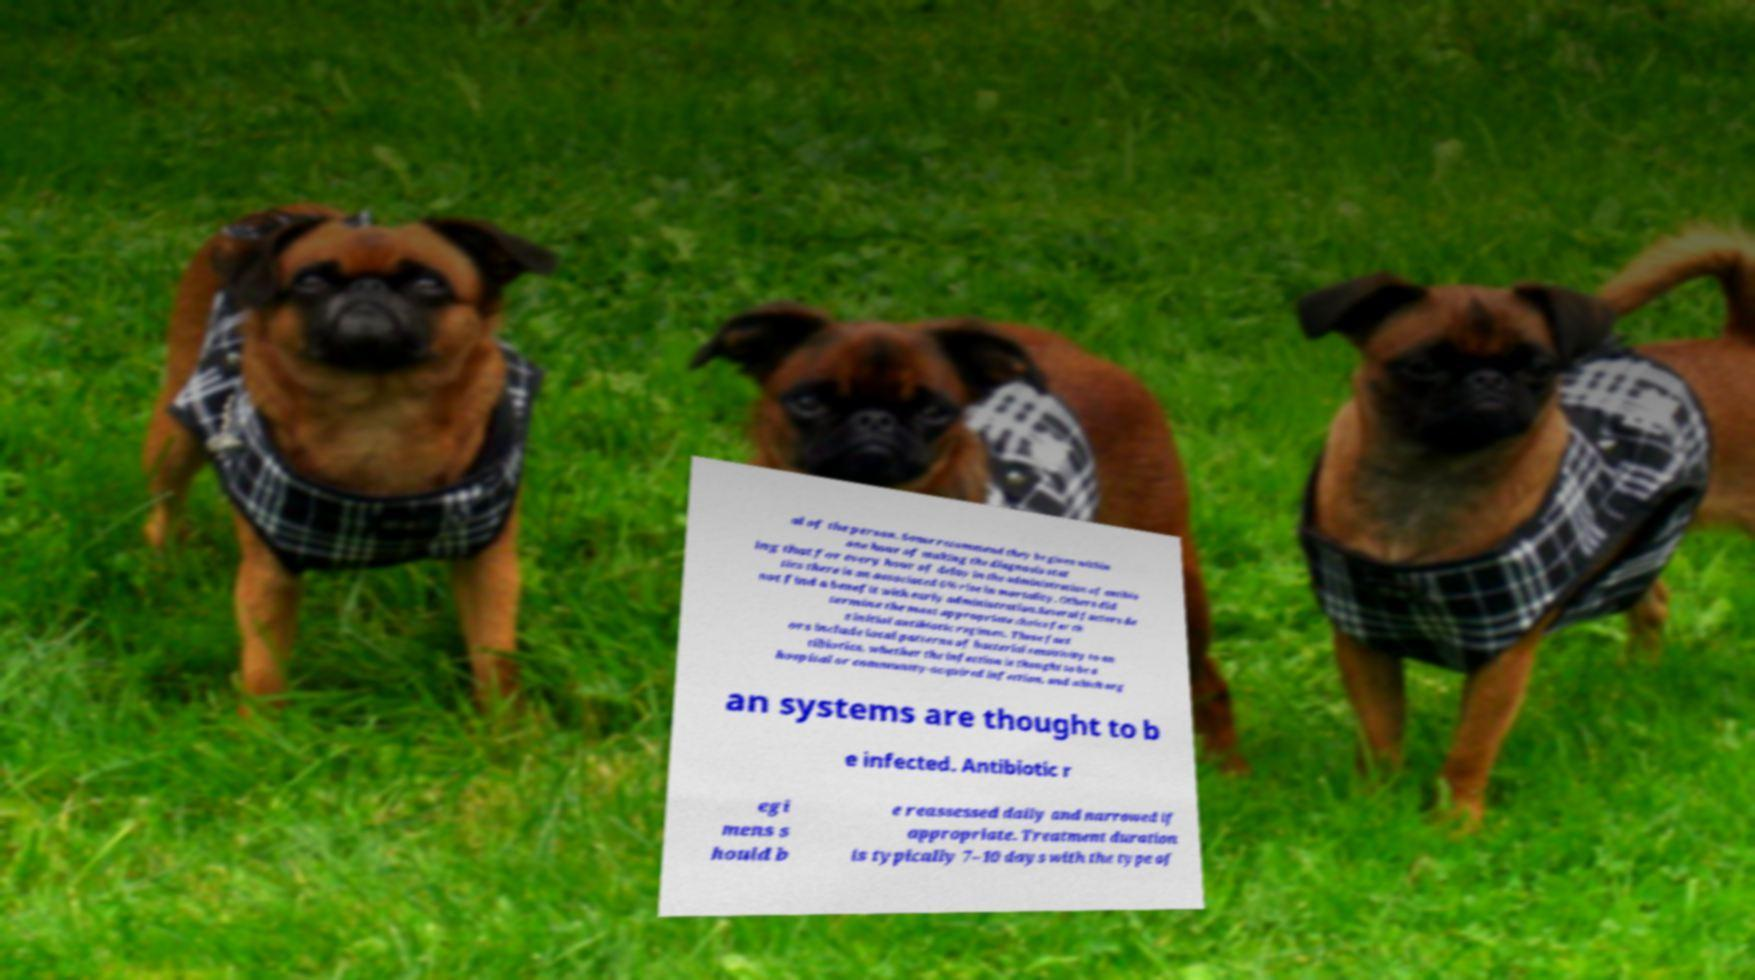Can you accurately transcribe the text from the provided image for me? al of the person. Some recommend they be given within one hour of making the diagnosis stat ing that for every hour of delay in the administration of antibio tics there is an associated 6% rise in mortality. Others did not find a benefit with early administration.Several factors de termine the most appropriate choice for th e initial antibiotic regimen. These fact ors include local patterns of bacterial sensitivity to an tibiotics, whether the infection is thought to be a hospital or community-acquired infection, and which org an systems are thought to b e infected. Antibiotic r egi mens s hould b e reassessed daily and narrowed if appropriate. Treatment duration is typically 7–10 days with the type of 